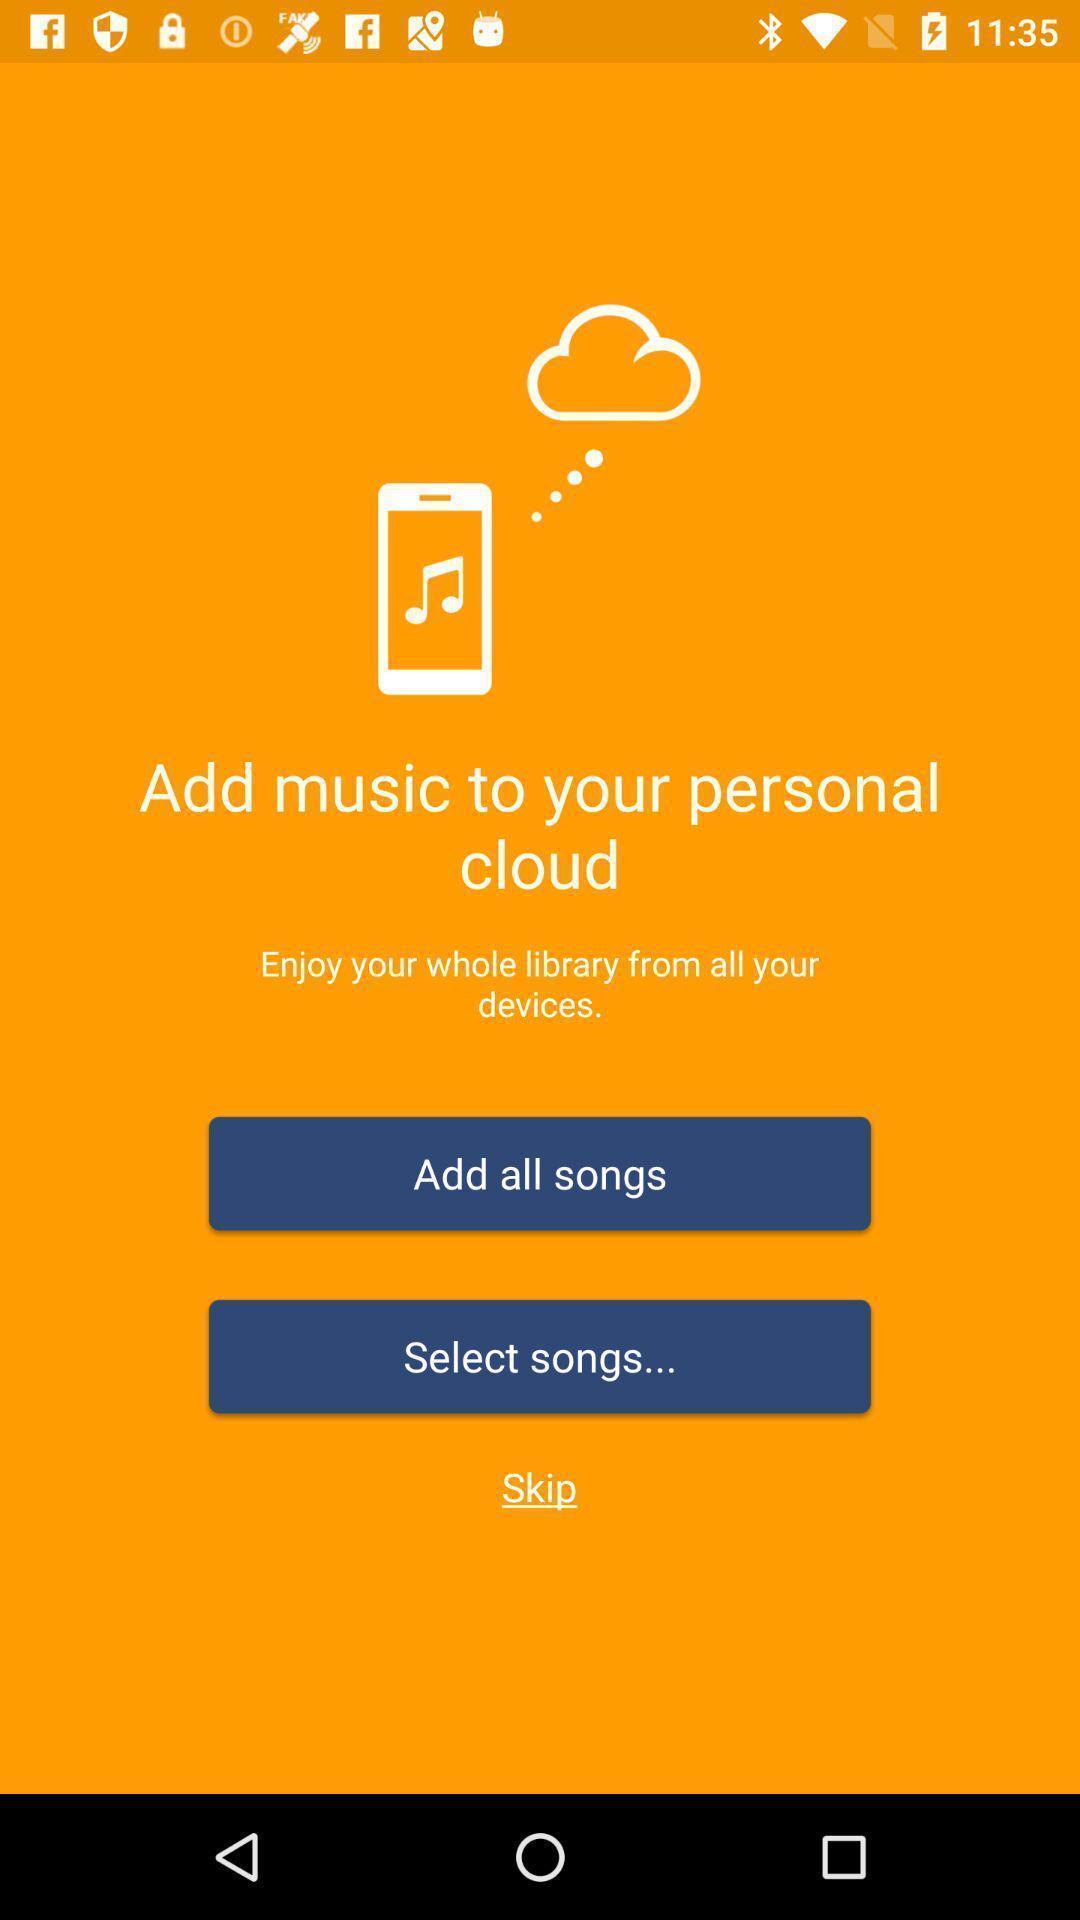Explain what's happening in this screen capture. Welcome page for adding songs in a music player app. 